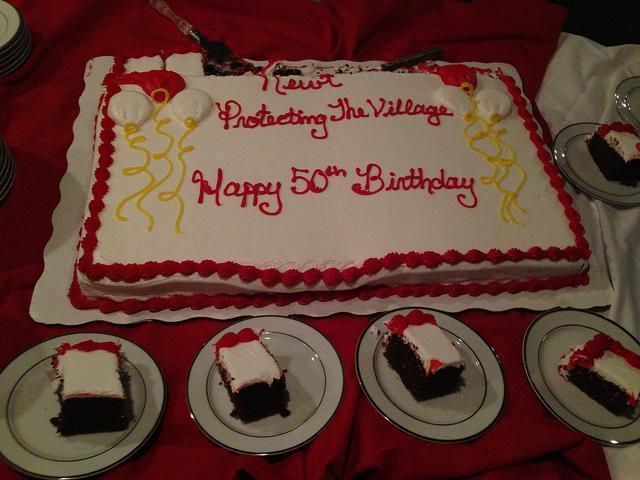The birthday boy has a name that refers to what kind of animal?
Make your selection and explain in format: 'Answer: answer
Rationale: rationale.'
Options: Salamander, cat, dog, bird. Answer: salamander.
Rationale: The name is "newt". newts are a species of salamanders. 